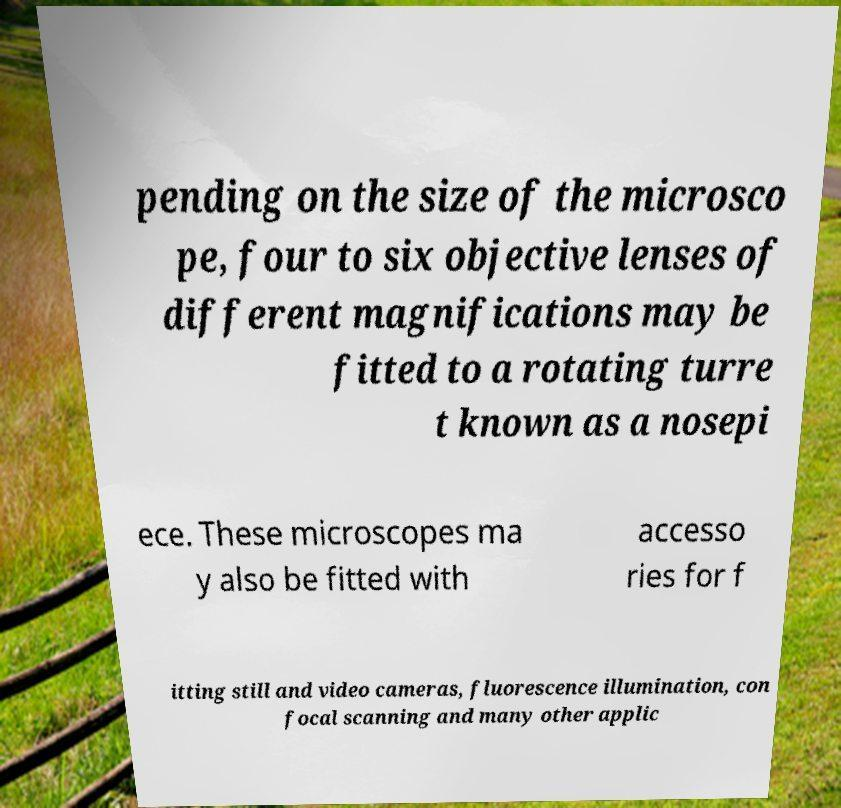Could you extract and type out the text from this image? pending on the size of the microsco pe, four to six objective lenses of different magnifications may be fitted to a rotating turre t known as a nosepi ece. These microscopes ma y also be fitted with accesso ries for f itting still and video cameras, fluorescence illumination, con focal scanning and many other applic 